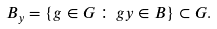Convert formula to latex. <formula><loc_0><loc_0><loc_500><loc_500>B _ { y } = \left \{ g \in G \, \colon \, g y \in B \right \} \subset G .</formula> 